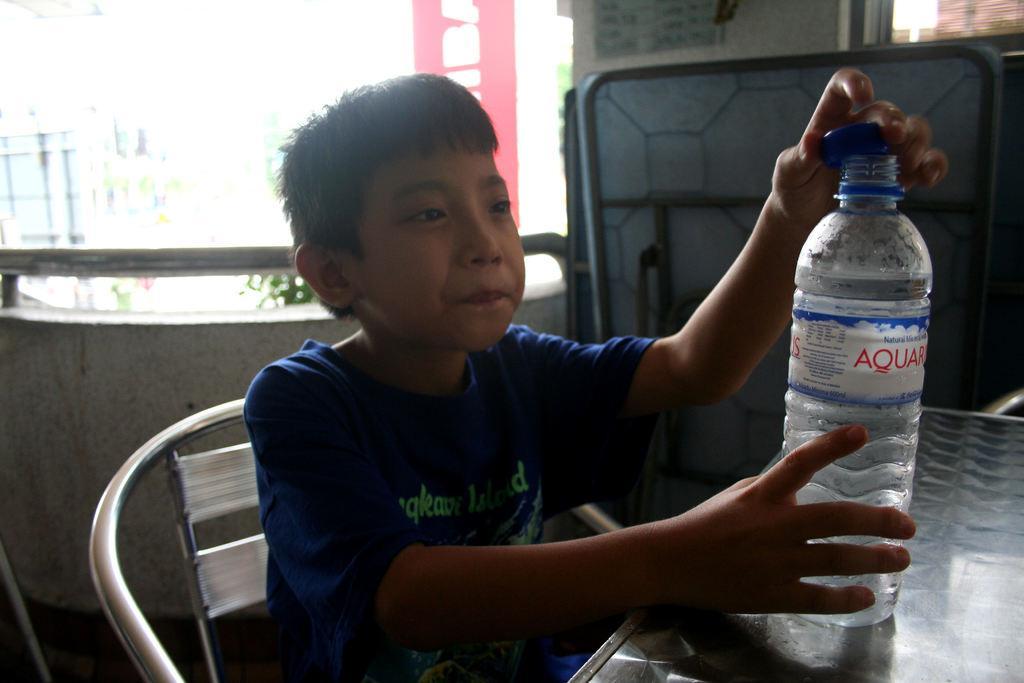How would you summarize this image in a sentence or two? In this picture we can see a boy sitting on the chair in front of the table and holding a bottle which is on the table. 